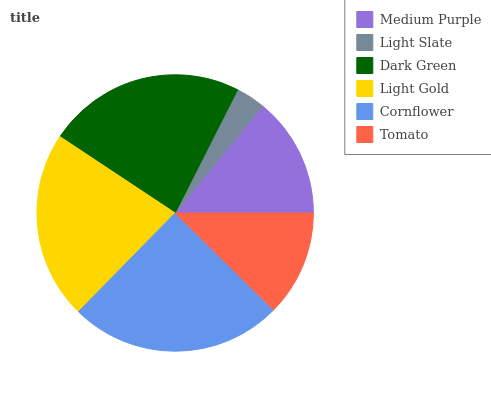Is Light Slate the minimum?
Answer yes or no. Yes. Is Cornflower the maximum?
Answer yes or no. Yes. Is Dark Green the minimum?
Answer yes or no. No. Is Dark Green the maximum?
Answer yes or no. No. Is Dark Green greater than Light Slate?
Answer yes or no. Yes. Is Light Slate less than Dark Green?
Answer yes or no. Yes. Is Light Slate greater than Dark Green?
Answer yes or no. No. Is Dark Green less than Light Slate?
Answer yes or no. No. Is Light Gold the high median?
Answer yes or no. Yes. Is Medium Purple the low median?
Answer yes or no. Yes. Is Dark Green the high median?
Answer yes or no. No. Is Light Gold the low median?
Answer yes or no. No. 